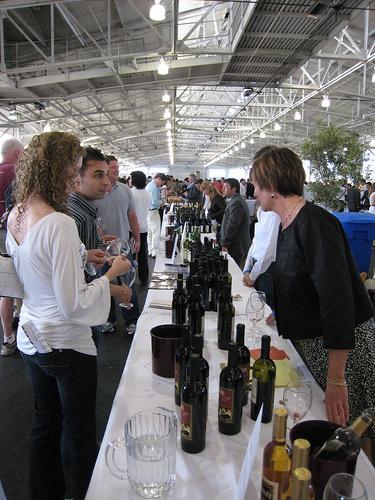Is this a wine tasting function?
Keep it brief. Yes. Is there a woman wearing a black shirt?
Concise answer only. Yes. What color are the tablecloths?
Concise answer only. White. What are the people in line on the far right waiting to do?
Keep it brief. Drink. 